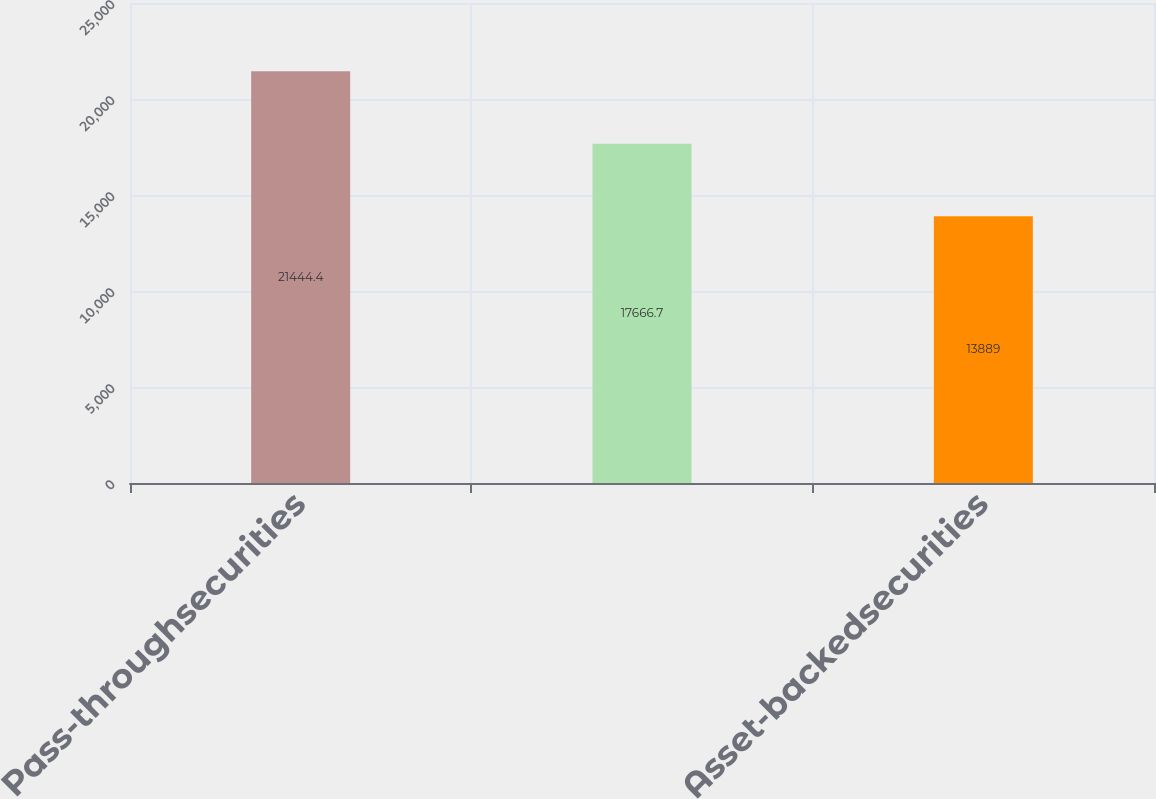<chart> <loc_0><loc_0><loc_500><loc_500><bar_chart><fcel>Pass-throughsecurities<fcel>Unnamed: 1<fcel>Asset-backedsecurities<nl><fcel>21444.4<fcel>17666.7<fcel>13889<nl></chart> 